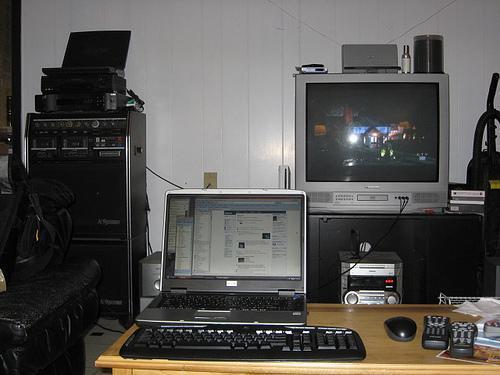How many keyboards are they?
Give a very brief answer. 2. How many TVs are there?
Give a very brief answer. 1. How many laptops are in the picture?
Give a very brief answer. 2. 